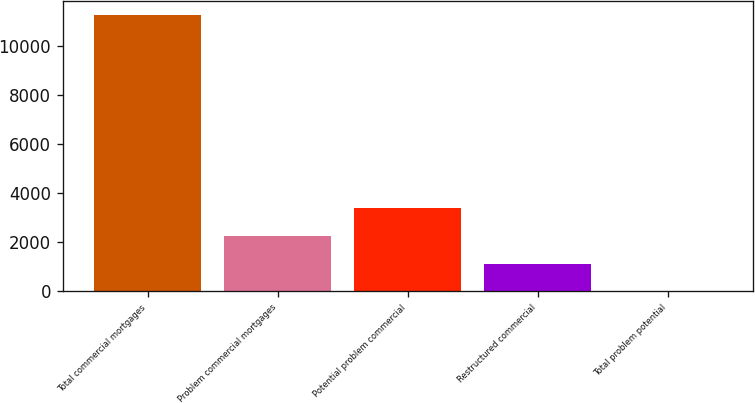<chart> <loc_0><loc_0><loc_500><loc_500><bar_chart><fcel>Total commercial mortgages<fcel>Problem commercial mortgages<fcel>Potential problem commercial<fcel>Restructured commercial<fcel>Total problem potential<nl><fcel>11279.3<fcel>2257.18<fcel>3384.95<fcel>1129.41<fcel>1.64<nl></chart> 